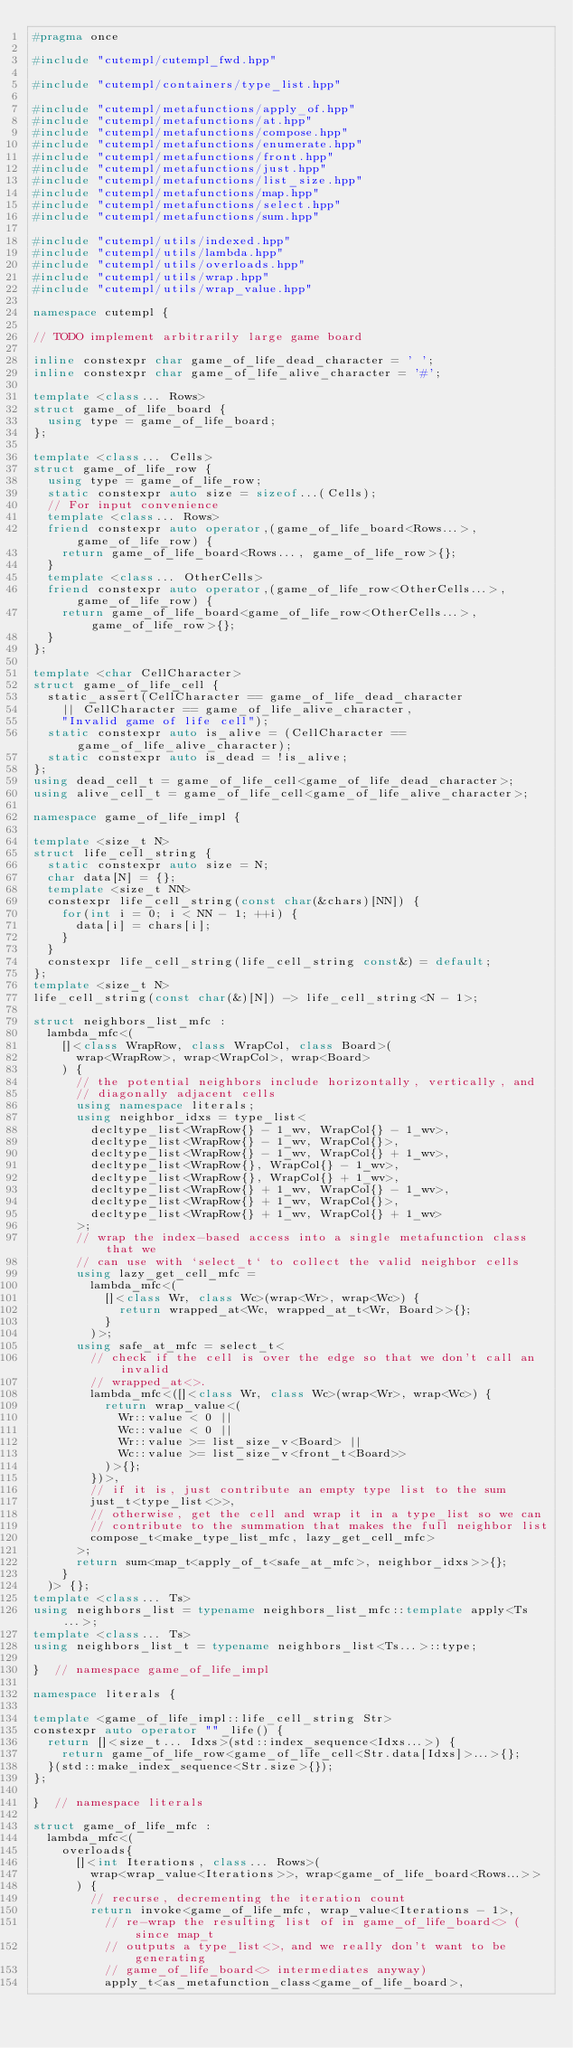Convert code to text. <code><loc_0><loc_0><loc_500><loc_500><_C++_>#pragma once

#include "cutempl/cutempl_fwd.hpp"

#include "cutempl/containers/type_list.hpp"

#include "cutempl/metafunctions/apply_of.hpp"
#include "cutempl/metafunctions/at.hpp"
#include "cutempl/metafunctions/compose.hpp"
#include "cutempl/metafunctions/enumerate.hpp"
#include "cutempl/metafunctions/front.hpp"
#include "cutempl/metafunctions/just.hpp"
#include "cutempl/metafunctions/list_size.hpp"
#include "cutempl/metafunctions/map.hpp"
#include "cutempl/metafunctions/select.hpp"
#include "cutempl/metafunctions/sum.hpp"

#include "cutempl/utils/indexed.hpp"
#include "cutempl/utils/lambda.hpp"
#include "cutempl/utils/overloads.hpp"
#include "cutempl/utils/wrap.hpp"
#include "cutempl/utils/wrap_value.hpp"

namespace cutempl {

// TODO implement arbitrarily large game board

inline constexpr char game_of_life_dead_character = ' ';
inline constexpr char game_of_life_alive_character = '#';

template <class... Rows>
struct game_of_life_board {
  using type = game_of_life_board;
};

template <class... Cells>
struct game_of_life_row {
  using type = game_of_life_row;
  static constexpr auto size = sizeof...(Cells);
  // For input convenience
  template <class... Rows>
  friend constexpr auto operator,(game_of_life_board<Rows...>, game_of_life_row) {
    return game_of_life_board<Rows..., game_of_life_row>{};
  }
  template <class... OtherCells>
  friend constexpr auto operator,(game_of_life_row<OtherCells...>, game_of_life_row) {
    return game_of_life_board<game_of_life_row<OtherCells...>, game_of_life_row>{};
  }
};

template <char CellCharacter>
struct game_of_life_cell {
  static_assert(CellCharacter == game_of_life_dead_character
    || CellCharacter == game_of_life_alive_character,
    "Invalid game of life cell");
  static constexpr auto is_alive = (CellCharacter == game_of_life_alive_character);
  static constexpr auto is_dead = !is_alive;
};
using dead_cell_t = game_of_life_cell<game_of_life_dead_character>;
using alive_cell_t = game_of_life_cell<game_of_life_alive_character>;

namespace game_of_life_impl {

template <size_t N>
struct life_cell_string {
  static constexpr auto size = N;
  char data[N] = {};
  template <size_t NN>
  constexpr life_cell_string(const char(&chars)[NN]) {
    for(int i = 0; i < NN - 1; ++i) {
      data[i] = chars[i];
    }
  }
  constexpr life_cell_string(life_cell_string const&) = default;
};
template <size_t N>
life_cell_string(const char(&)[N]) -> life_cell_string<N - 1>;

struct neighbors_list_mfc :
  lambda_mfc<(
    []<class WrapRow, class WrapCol, class Board>(
      wrap<WrapRow>, wrap<WrapCol>, wrap<Board>
    ) {
      // the potential neighbors include horizontally, vertically, and
      // diagonally adjacent cells
      using namespace literals;
      using neighbor_idxs = type_list<
        decltype_list<WrapRow{} - 1_wv, WrapCol{} - 1_wv>,
        decltype_list<WrapRow{} - 1_wv, WrapCol{}>,
        decltype_list<WrapRow{} - 1_wv, WrapCol{} + 1_wv>,
        decltype_list<WrapRow{}, WrapCol{} - 1_wv>,
        decltype_list<WrapRow{}, WrapCol{} + 1_wv>,
        decltype_list<WrapRow{} + 1_wv, WrapCol{} - 1_wv>,
        decltype_list<WrapRow{} + 1_wv, WrapCol{}>,
        decltype_list<WrapRow{} + 1_wv, WrapCol{} + 1_wv>
      >;
      // wrap the index-based access into a single metafunction class that we
      // can use with `select_t` to collect the valid neighbor cells
      using lazy_get_cell_mfc =
        lambda_mfc<(
          []<class Wr, class Wc>(wrap<Wr>, wrap<Wc>) {
            return wrapped_at<Wc, wrapped_at_t<Wr, Board>>{};
          }
        )>;
      using safe_at_mfc = select_t<
        // check if the cell is over the edge so that we don't call an invalid
        // wrapped_at<>.
        lambda_mfc<([]<class Wr, class Wc>(wrap<Wr>, wrap<Wc>) {
          return wrap_value<(
            Wr::value < 0 ||
            Wc::value < 0 ||
            Wr::value >= list_size_v<Board> ||
            Wc::value >= list_size_v<front_t<Board>>
          )>{};
        })>,
        // if it is, just contribute an empty type list to the sum
        just_t<type_list<>>,
        // otherwise, get the cell and wrap it in a type_list so we can
        // contribute to the summation that makes the full neighbor list
        compose_t<make_type_list_mfc, lazy_get_cell_mfc>
      >;
      return sum<map_t<apply_of_t<safe_at_mfc>, neighbor_idxs>>{};
    }
  )> {};
template <class... Ts>
using neighbors_list = typename neighbors_list_mfc::template apply<Ts...>;
template <class... Ts>
using neighbors_list_t = typename neighbors_list<Ts...>::type;

}  // namespace game_of_life_impl

namespace literals {

template <game_of_life_impl::life_cell_string Str>
constexpr auto operator ""_life() {
  return []<size_t... Idxs>(std::index_sequence<Idxs...>) {
    return game_of_life_row<game_of_life_cell<Str.data[Idxs]>...>{};
  }(std::make_index_sequence<Str.size>{});
};

}  // namespace literals

struct game_of_life_mfc :
  lambda_mfc<(
    overloads{
      []<int Iterations, class... Rows>(
        wrap<wrap_value<Iterations>>, wrap<game_of_life_board<Rows...>>
      ) {
        // recurse, decrementing the iteration count
        return invoke<game_of_life_mfc, wrap_value<Iterations - 1>,
          // re-wrap the resulting list of in game_of_life_board<> (since map_t
          // outputs a type_list<>, and we really don't want to be generating
          // game_of_life_board<> intermediates anyway)
          apply_t<as_metafunction_class<game_of_life_board>,</code> 